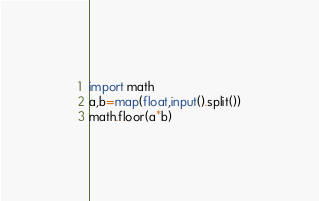Convert code to text. <code><loc_0><loc_0><loc_500><loc_500><_Python_>import math
a,b=map(float,input().split())
math.floor(a*b)</code> 